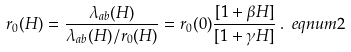Convert formula to latex. <formula><loc_0><loc_0><loc_500><loc_500>r _ { 0 } ( H ) = \frac { \lambda _ { a b } ( H ) } { \lambda _ { a b } ( H ) / r _ { 0 } ( H ) } = r _ { 0 } ( 0 ) \frac { [ 1 + \beta H ] } { [ 1 + \gamma H ] } \, . \ e q n u m { 2 }</formula> 